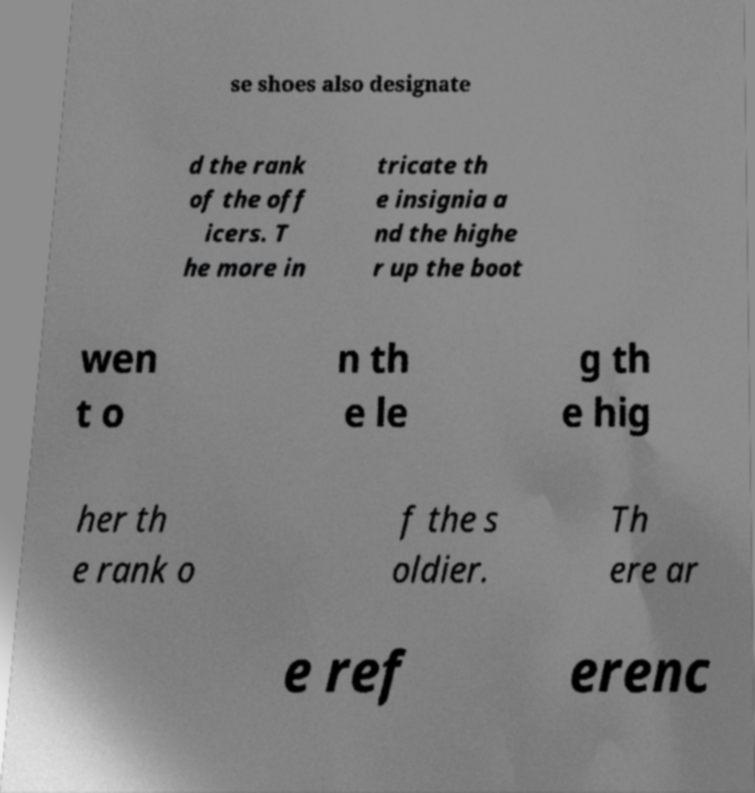Can you read and provide the text displayed in the image?This photo seems to have some interesting text. Can you extract and type it out for me? se shoes also designate d the rank of the off icers. T he more in tricate th e insignia a nd the highe r up the boot wen t o n th e le g th e hig her th e rank o f the s oldier. Th ere ar e ref erenc 